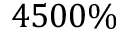Convert formula to latex. <formula><loc_0><loc_0><loc_500><loc_500>4 5 0 0 \%</formula> 